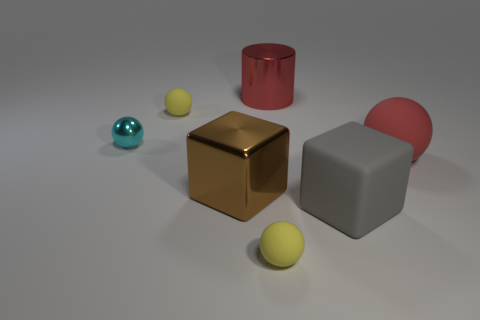How many other objects are the same color as the big rubber block?
Your answer should be compact. 0. There is a object that is both right of the big brown metallic cube and behind the large rubber sphere; what is its color?
Your response must be concise. Red. How big is the matte ball right of the big cylinder behind the large metal thing that is left of the large red cylinder?
Your answer should be very brief. Large. How many things are either large metallic blocks that are in front of the tiny cyan thing or large objects right of the big red cylinder?
Offer a very short reply. 3. What is the shape of the red matte object?
Your response must be concise. Sphere. How many other things are there of the same material as the brown object?
Your answer should be very brief. 2. There is another metal object that is the same shape as the large gray object; what is its size?
Give a very brief answer. Large. There is a large block that is right of the yellow rubber object that is in front of the large cube that is in front of the metallic cube; what is it made of?
Make the answer very short. Rubber. Are there any small cyan metal things?
Your response must be concise. Yes. There is a large metal cylinder; does it have the same color as the ball behind the cyan metal ball?
Make the answer very short. No. 